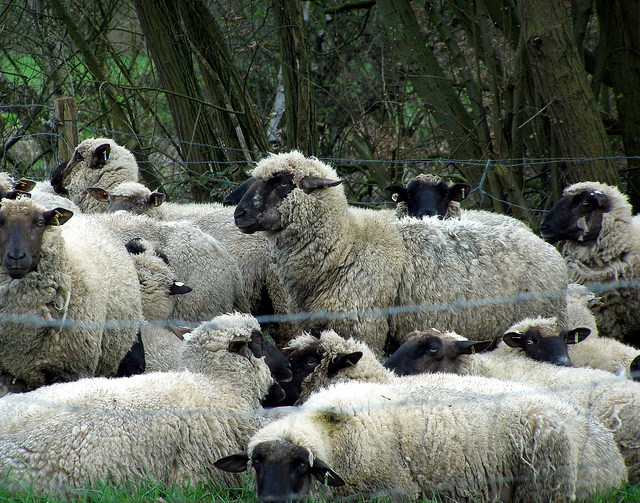How many sheep can you see in the image? There are numerous sheep visible in the image. By carefully counting, I can see 16 sheep. They are gathered closely, making it a bit challenging to distinguish each one clearly. 